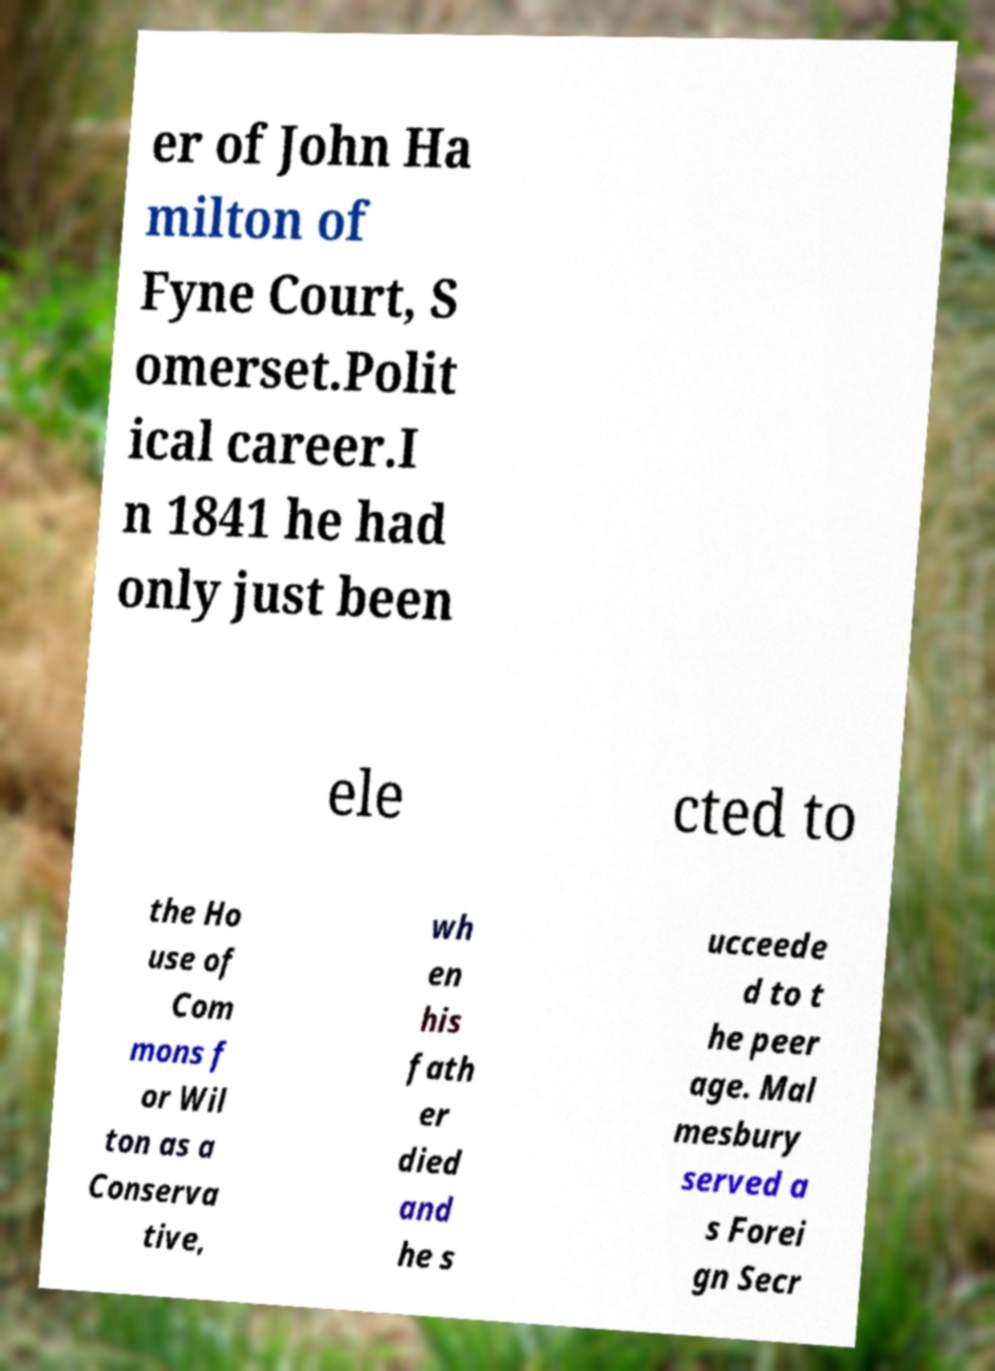Could you extract and type out the text from this image? er of John Ha milton of Fyne Court, S omerset.Polit ical career.I n 1841 he had only just been ele cted to the Ho use of Com mons f or Wil ton as a Conserva tive, wh en his fath er died and he s ucceede d to t he peer age. Mal mesbury served a s Forei gn Secr 